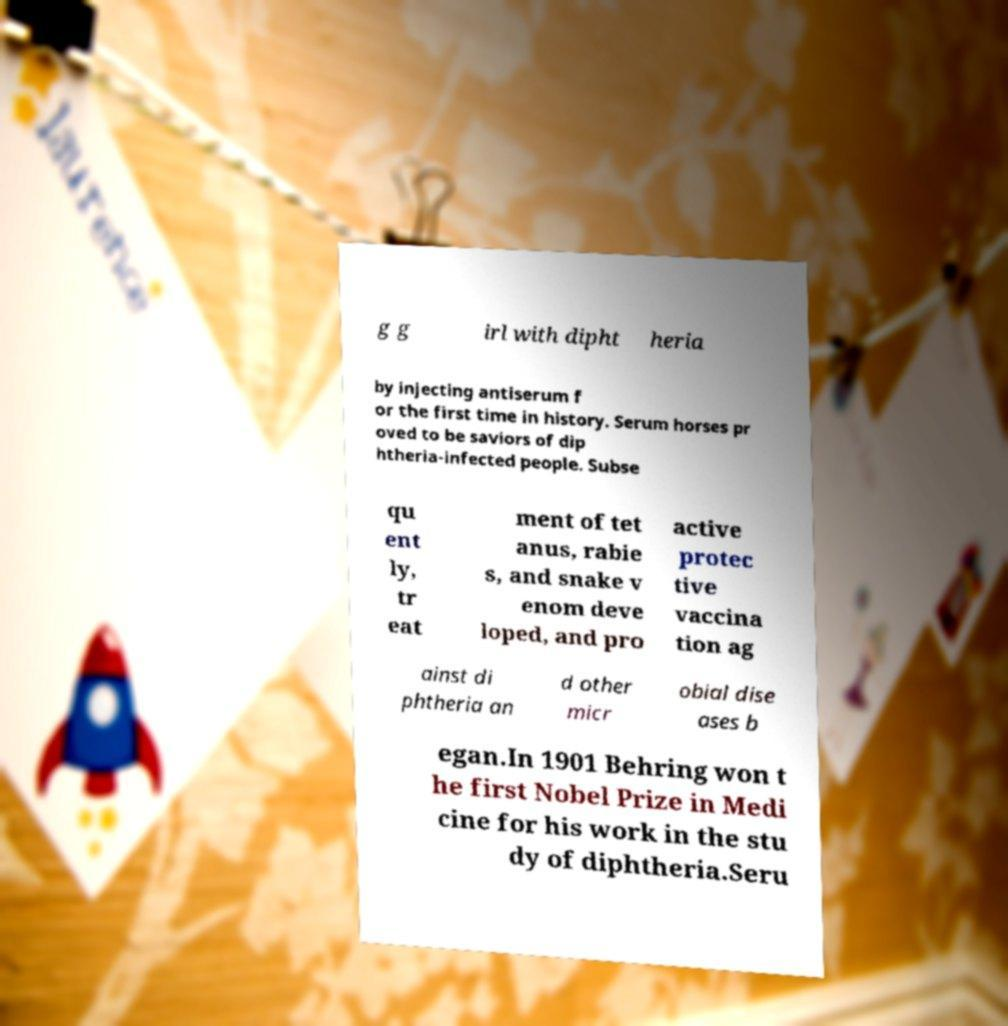I need the written content from this picture converted into text. Can you do that? g g irl with dipht heria by injecting antiserum f or the first time in history. Serum horses pr oved to be saviors of dip htheria-infected people. Subse qu ent ly, tr eat ment of tet anus, rabie s, and snake v enom deve loped, and pro active protec tive vaccina tion ag ainst di phtheria an d other micr obial dise ases b egan.In 1901 Behring won t he first Nobel Prize in Medi cine for his work in the stu dy of diphtheria.Seru 